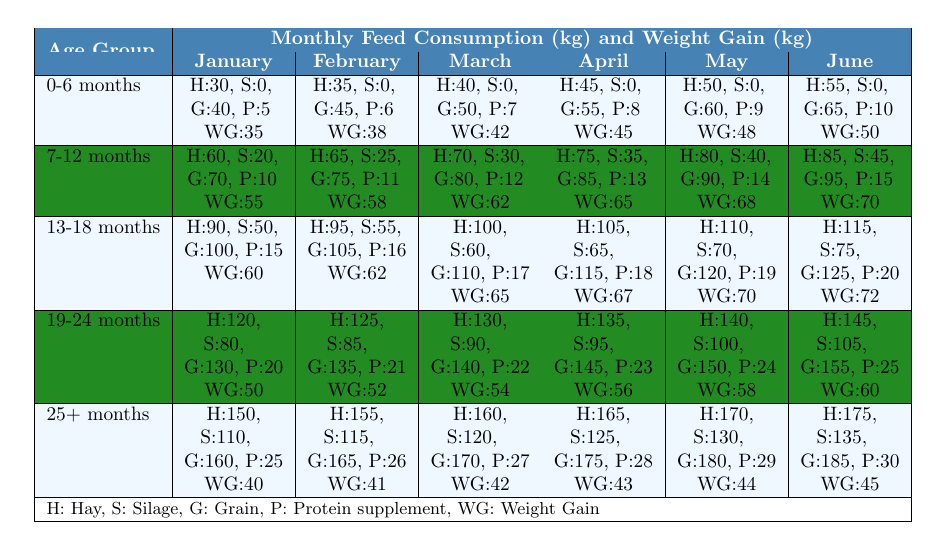What is the weight gain of cattle aged 19-24 months in June? By examining the June row for the age group 19-24 months in the table, the weight gain listed is 60.
Answer: 60 How much Hay do 13-18 month old cattle consume in March? Looking at the March row for the age group 13-18 months, the Hay consumption is recorded as 100 kg.
Answer: 100 kg What is the total feed consumption for 0-6 months old cattle in February? In February for the 0-6 months age group, Hay is 35 kg, Silage is 0 kg, Grain is 45 kg, and Protein supplement is 6 kg. Therefore, total feed consumption is 35 + 0 + 45 + 6 = 86 kg.
Answer: 86 kg Is the weight gain for cattle aged 25+ months higher in June than in January? In June, the weight gain for 25+ months cattle is 45, while in January it is 40. Since 45 is greater than 40, the statement is true.
Answer: Yes What is the average weight gain for cattle aged 7-12 months across the six months? The weight gains for 7-12 months in the six months are 55, 58, 62, 65, 68, and 70. The sum of these values is 55 + 58 + 62 + 65 + 68 + 70 = 388, and the average is 388 / 6 = 64.67.
Answer: 64.67 Which age group shows the highest grain feed consumption in April? Looking at the April row, the grain feed consumption values are: 55 for 0-6 months, 85 for 7-12 months, 115 for 13-18 months, 145 for 19-24 months, and 175 for 25+ months. The maximum value here is 175 kg, which belongs to the 25+ months age group.
Answer: 25+ months What is the difference in weight gain between the 0-6 months and the 25+ months age group in May? The weight gain for 0-6 months in May is 48, and for 25+ months, it is 44. The difference is 48 - 44 = 4 kg.
Answer: 4 kg Which month had the highest protein supplement feed consumption for 19-24 months cattle? In the table for the 19-24 months age group, the protein supplement consumption across the months is as follows: January (20), February (21), March (22), April (23), May (24), June (25). The highest is 25 kg, recorded in June.
Answer: June Does the feed consumption for Silage increase, decrease, or remain constant for cattle aged 13-18 months from January to June? Observing the Silage consumption for 13-18 months: January (50), February (55), March (60), April (65), May (70), June (75). The values show an increase throughout these months.
Answer: Increase What is the total weight gain of cattle aged 7-12 months from January to April? The weight gains for the age group 7-12 months over these months are: 55 (January), 58 (February), 62 (March), and 65 (April). The total weight gain is 55 + 58 + 62 + 65 = 240 kg.
Answer: 240 kg 